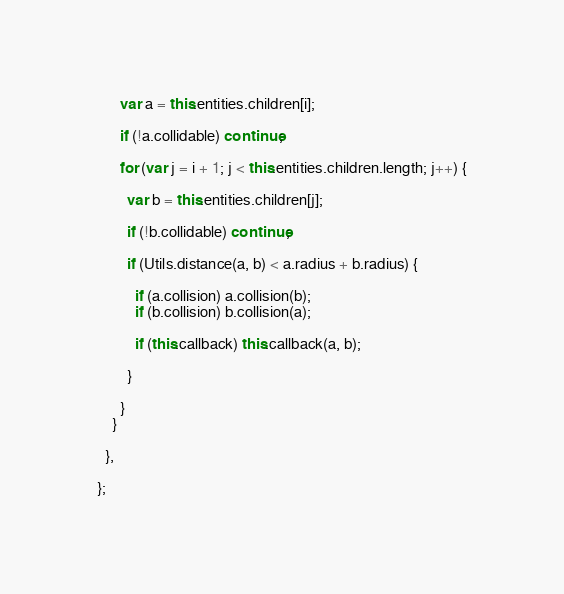Convert code to text. <code><loc_0><loc_0><loc_500><loc_500><_JavaScript_>      var a = this.entities.children[i];

      if (!a.collidable) continue;

      for (var j = i + 1; j < this.entities.children.length; j++) {

        var b = this.entities.children[j];

        if (!b.collidable) continue;

        if (Utils.distance(a, b) < a.radius + b.radius) {

          if (a.collision) a.collision(b);
          if (b.collision) b.collision(a);

          if (this.callback) this.callback(a, b);

        }

      }
    }

  },

};</code> 